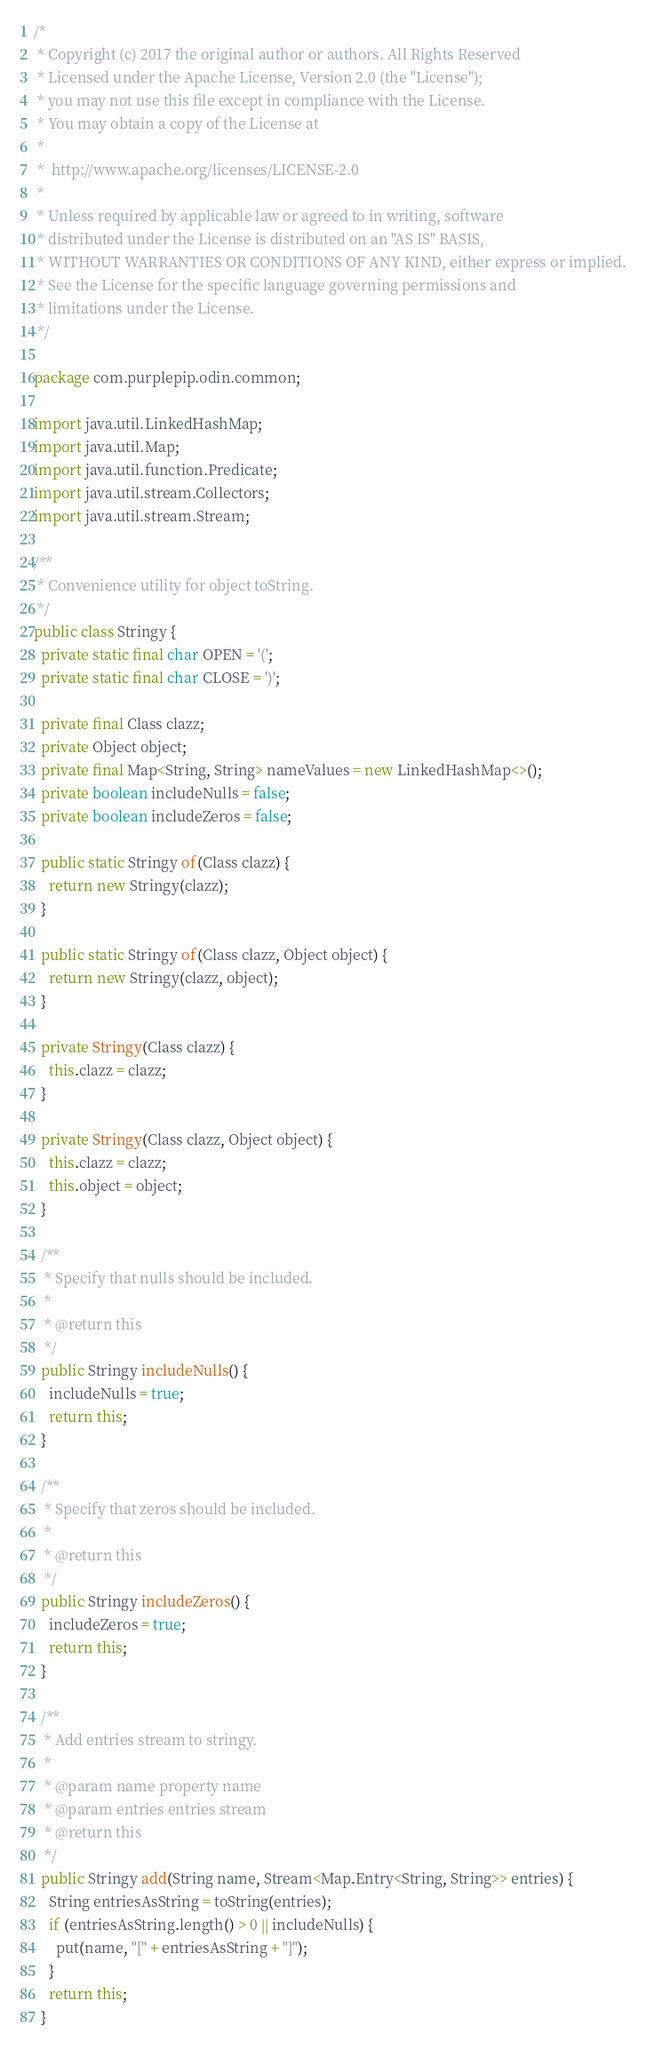Convert code to text. <code><loc_0><loc_0><loc_500><loc_500><_Java_>/*
 * Copyright (c) 2017 the original author or authors. All Rights Reserved
 * Licensed under the Apache License, Version 2.0 (the "License");
 * you may not use this file except in compliance with the License.
 * You may obtain a copy of the License at
 *
 *  http://www.apache.org/licenses/LICENSE-2.0
 *
 * Unless required by applicable law or agreed to in writing, software
 * distributed under the License is distributed on an "AS IS" BASIS,
 * WITHOUT WARRANTIES OR CONDITIONS OF ANY KIND, either express or implied.
 * See the License for the specific language governing permissions and
 * limitations under the License.
 */

package com.purplepip.odin.common;

import java.util.LinkedHashMap;
import java.util.Map;
import java.util.function.Predicate;
import java.util.stream.Collectors;
import java.util.stream.Stream;

/**
 * Convenience utility for object toString.
 */
public class Stringy {
  private static final char OPEN = '(';
  private static final char CLOSE = ')';

  private final Class clazz;
  private Object object;
  private final Map<String, String> nameValues = new LinkedHashMap<>();
  private boolean includeNulls = false;
  private boolean includeZeros = false;

  public static Stringy of(Class clazz) {
    return new Stringy(clazz);
  }

  public static Stringy of(Class clazz, Object object) {
    return new Stringy(clazz, object);
  }

  private Stringy(Class clazz) {
    this.clazz = clazz;
  }

  private Stringy(Class clazz, Object object) {
    this.clazz = clazz;
    this.object = object;
  }

  /**
   * Specify that nulls should be included.
   *
   * @return this
   */
  public Stringy includeNulls() {
    includeNulls = true;
    return this;
  }

  /**
   * Specify that zeros should be included.
   *
   * @return this
   */
  public Stringy includeZeros() {
    includeZeros = true;
    return this;
  }

  /**
   * Add entries stream to stringy.
   *
   * @param name property name
   * @param entries entries stream
   * @return this
   */
  public Stringy add(String name, Stream<Map.Entry<String, String>> entries) {
    String entriesAsString = toString(entries);
    if (entriesAsString.length() > 0 || includeNulls) {
      put(name, "[" + entriesAsString + "]");
    }
    return this;
  }
</code> 